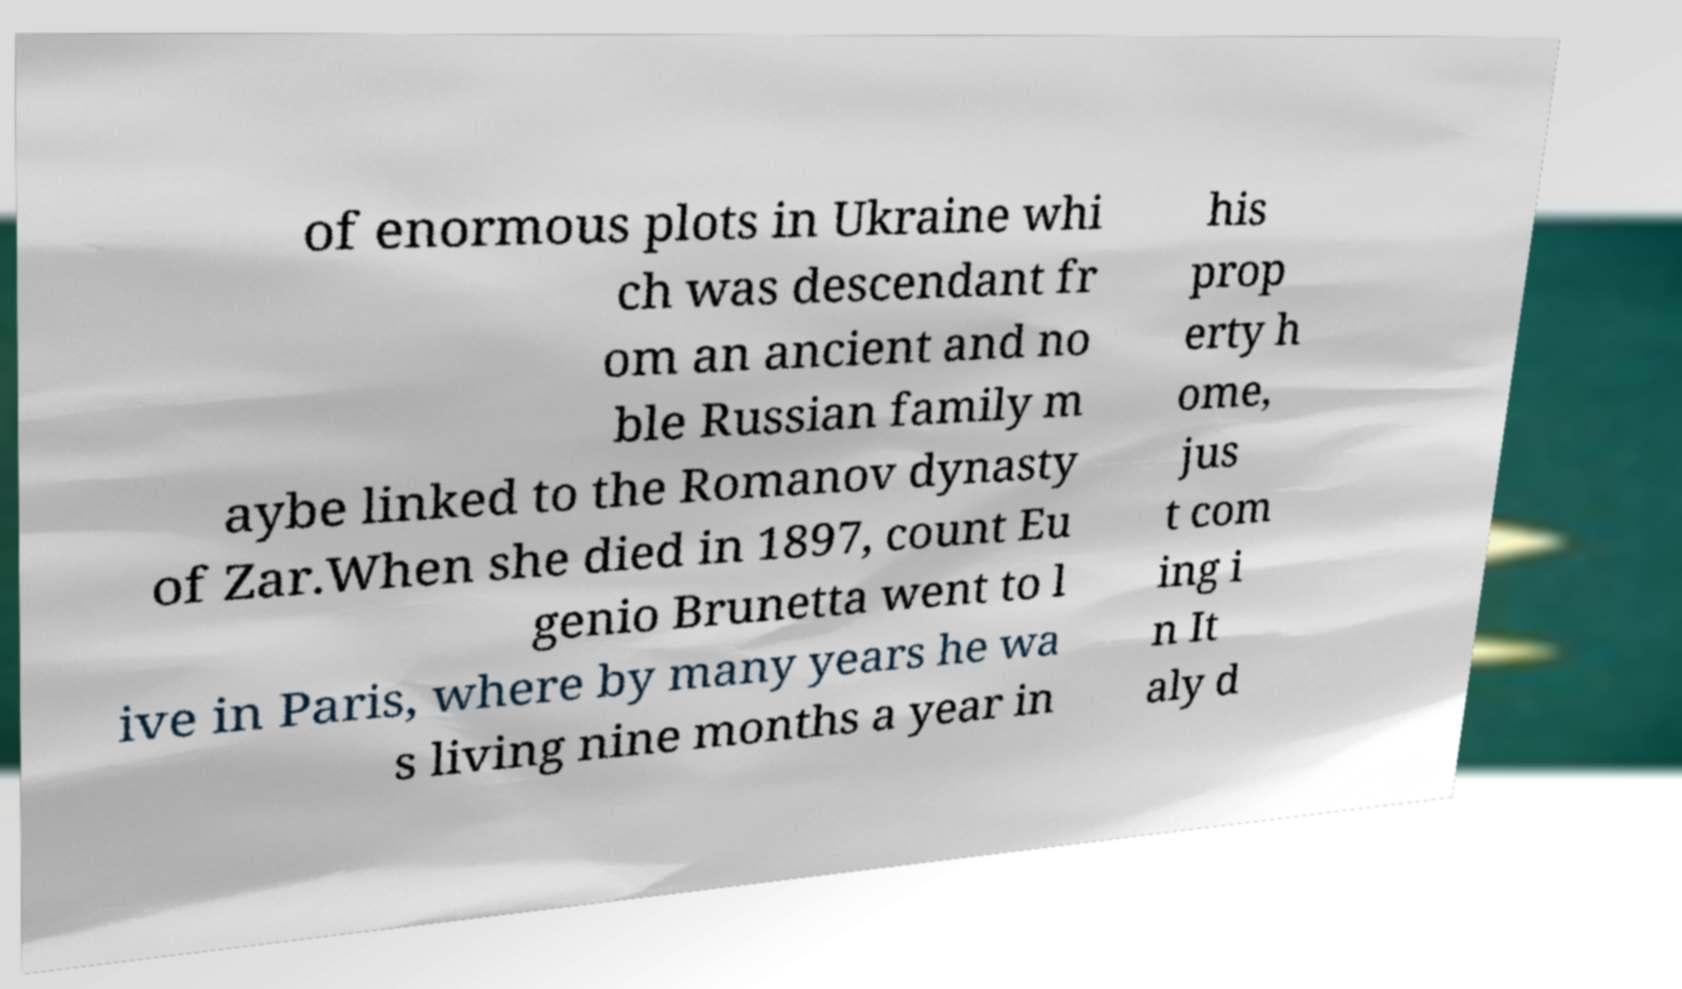Could you assist in decoding the text presented in this image and type it out clearly? of enormous plots in Ukraine whi ch was descendant fr om an ancient and no ble Russian family m aybe linked to the Romanov dynasty of Zar.When she died in 1897, count Eu genio Brunetta went to l ive in Paris, where by many years he wa s living nine months a year in his prop erty h ome, jus t com ing i n It aly d 